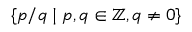<formula> <loc_0><loc_0><loc_500><loc_500>\{ p / q | p , q \in \mathbb { Z } , q \not = 0 \}</formula> 